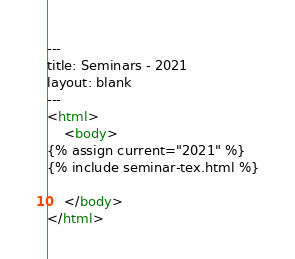<code> <loc_0><loc_0><loc_500><loc_500><_HTML_>---
title: Seminars - 2021
layout: blank
---
<html>
    <body>
{% assign current="2021" %}
{% include seminar-tex.html %}
            
    </body>
</html>
</code> 